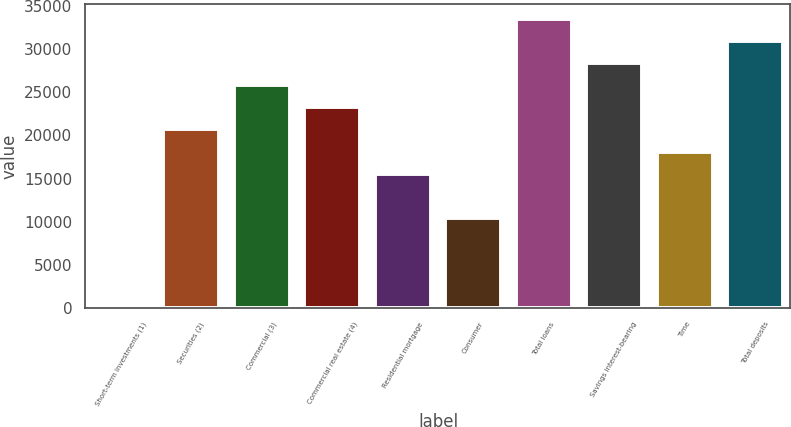Convert chart. <chart><loc_0><loc_0><loc_500><loc_500><bar_chart><fcel>Short-term investments (1)<fcel>Securities (2)<fcel>Commercial (3)<fcel>Commercial real estate (4)<fcel>Residential mortgage<fcel>Consumer<fcel>Total loans<fcel>Savings interest-bearing<fcel>Time<fcel>Total deposits<nl><fcel>156.1<fcel>20688.4<fcel>25821.5<fcel>23255<fcel>15555.3<fcel>10422.3<fcel>33521.1<fcel>28388<fcel>18121.9<fcel>30954.6<nl></chart> 